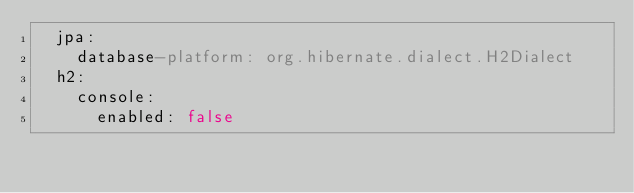<code> <loc_0><loc_0><loc_500><loc_500><_YAML_>  jpa:
    database-platform: org.hibernate.dialect.H2Dialect
  h2:
    console:
      enabled: false</code> 